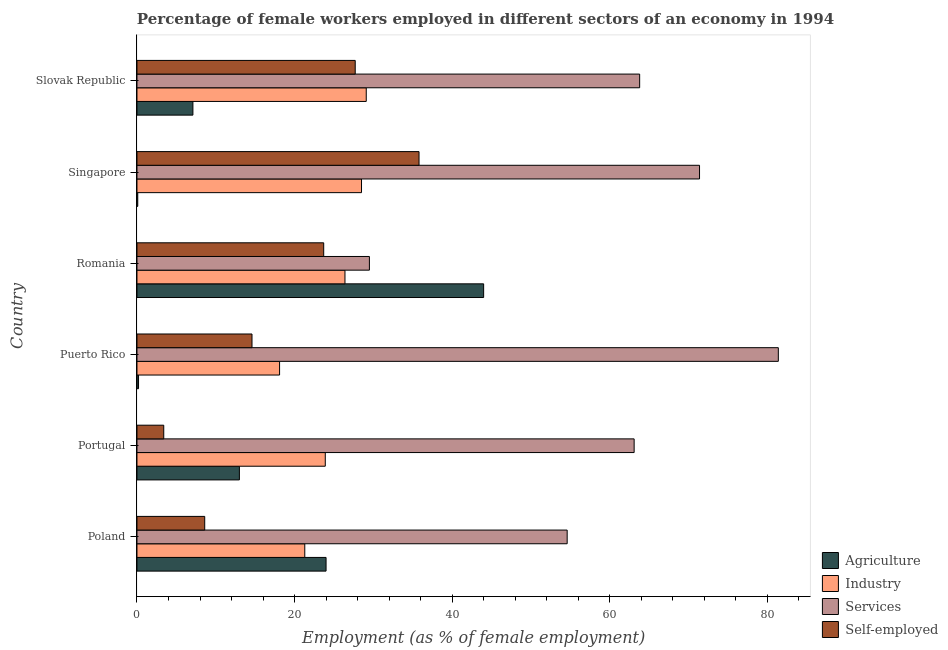How many groups of bars are there?
Offer a terse response. 6. Are the number of bars on each tick of the Y-axis equal?
Make the answer very short. Yes. What is the label of the 1st group of bars from the top?
Provide a succinct answer. Slovak Republic. In how many cases, is the number of bars for a given country not equal to the number of legend labels?
Make the answer very short. 0. What is the percentage of female workers in services in Romania?
Ensure brevity in your answer.  29.5. Across all countries, what is the minimum percentage of female workers in industry?
Keep it short and to the point. 18.1. In which country was the percentage of self employed female workers maximum?
Your answer should be very brief. Singapore. In which country was the percentage of female workers in agriculture minimum?
Your answer should be compact. Singapore. What is the total percentage of female workers in industry in the graph?
Offer a very short reply. 147.3. What is the difference between the percentage of female workers in services in Poland and the percentage of female workers in agriculture in Singapore?
Make the answer very short. 54.5. What is the average percentage of female workers in agriculture per country?
Give a very brief answer. 14.73. What is the difference between the percentage of self employed female workers and percentage of female workers in services in Slovak Republic?
Your answer should be compact. -36.1. What is the ratio of the percentage of female workers in industry in Puerto Rico to that in Slovak Republic?
Offer a terse response. 0.62. Is the percentage of female workers in services in Romania less than that in Slovak Republic?
Keep it short and to the point. Yes. What is the difference between the highest and the second highest percentage of female workers in agriculture?
Keep it short and to the point. 20. What is the difference between the highest and the lowest percentage of female workers in services?
Ensure brevity in your answer.  51.9. Is the sum of the percentage of self employed female workers in Puerto Rico and Romania greater than the maximum percentage of female workers in services across all countries?
Your answer should be very brief. No. What does the 4th bar from the top in Puerto Rico represents?
Make the answer very short. Agriculture. What does the 2nd bar from the bottom in Poland represents?
Give a very brief answer. Industry. Is it the case that in every country, the sum of the percentage of female workers in agriculture and percentage of female workers in industry is greater than the percentage of female workers in services?
Give a very brief answer. No. How many bars are there?
Provide a succinct answer. 24. How many countries are there in the graph?
Provide a succinct answer. 6. Are the values on the major ticks of X-axis written in scientific E-notation?
Keep it short and to the point. No. Does the graph contain grids?
Make the answer very short. No. Where does the legend appear in the graph?
Make the answer very short. Bottom right. What is the title of the graph?
Provide a short and direct response. Percentage of female workers employed in different sectors of an economy in 1994. Does "Agricultural land" appear as one of the legend labels in the graph?
Make the answer very short. No. What is the label or title of the X-axis?
Your answer should be compact. Employment (as % of female employment). What is the Employment (as % of female employment) of Agriculture in Poland?
Give a very brief answer. 24. What is the Employment (as % of female employment) of Industry in Poland?
Ensure brevity in your answer.  21.3. What is the Employment (as % of female employment) in Services in Poland?
Provide a succinct answer. 54.6. What is the Employment (as % of female employment) of Self-employed in Poland?
Provide a short and direct response. 8.6. What is the Employment (as % of female employment) of Industry in Portugal?
Give a very brief answer. 23.9. What is the Employment (as % of female employment) of Services in Portugal?
Offer a terse response. 63.1. What is the Employment (as % of female employment) of Self-employed in Portugal?
Offer a very short reply. 3.4. What is the Employment (as % of female employment) in Agriculture in Puerto Rico?
Your answer should be compact. 0.2. What is the Employment (as % of female employment) of Industry in Puerto Rico?
Keep it short and to the point. 18.1. What is the Employment (as % of female employment) of Services in Puerto Rico?
Ensure brevity in your answer.  81.4. What is the Employment (as % of female employment) of Self-employed in Puerto Rico?
Keep it short and to the point. 14.6. What is the Employment (as % of female employment) of Agriculture in Romania?
Keep it short and to the point. 44. What is the Employment (as % of female employment) in Industry in Romania?
Offer a very short reply. 26.4. What is the Employment (as % of female employment) in Services in Romania?
Keep it short and to the point. 29.5. What is the Employment (as % of female employment) in Self-employed in Romania?
Ensure brevity in your answer.  23.7. What is the Employment (as % of female employment) of Agriculture in Singapore?
Keep it short and to the point. 0.1. What is the Employment (as % of female employment) of Industry in Singapore?
Ensure brevity in your answer.  28.5. What is the Employment (as % of female employment) in Services in Singapore?
Give a very brief answer. 71.4. What is the Employment (as % of female employment) of Self-employed in Singapore?
Ensure brevity in your answer.  35.8. What is the Employment (as % of female employment) of Agriculture in Slovak Republic?
Your answer should be very brief. 7.1. What is the Employment (as % of female employment) of Industry in Slovak Republic?
Your response must be concise. 29.1. What is the Employment (as % of female employment) of Services in Slovak Republic?
Provide a succinct answer. 63.8. What is the Employment (as % of female employment) of Self-employed in Slovak Republic?
Your answer should be very brief. 27.7. Across all countries, what is the maximum Employment (as % of female employment) in Agriculture?
Provide a succinct answer. 44. Across all countries, what is the maximum Employment (as % of female employment) of Industry?
Offer a very short reply. 29.1. Across all countries, what is the maximum Employment (as % of female employment) of Services?
Your answer should be very brief. 81.4. Across all countries, what is the maximum Employment (as % of female employment) in Self-employed?
Your answer should be compact. 35.8. Across all countries, what is the minimum Employment (as % of female employment) in Agriculture?
Your answer should be very brief. 0.1. Across all countries, what is the minimum Employment (as % of female employment) in Industry?
Offer a terse response. 18.1. Across all countries, what is the minimum Employment (as % of female employment) of Services?
Offer a very short reply. 29.5. Across all countries, what is the minimum Employment (as % of female employment) of Self-employed?
Provide a succinct answer. 3.4. What is the total Employment (as % of female employment) of Agriculture in the graph?
Keep it short and to the point. 88.4. What is the total Employment (as % of female employment) in Industry in the graph?
Provide a succinct answer. 147.3. What is the total Employment (as % of female employment) in Services in the graph?
Ensure brevity in your answer.  363.8. What is the total Employment (as % of female employment) of Self-employed in the graph?
Ensure brevity in your answer.  113.8. What is the difference between the Employment (as % of female employment) of Agriculture in Poland and that in Portugal?
Your answer should be compact. 11. What is the difference between the Employment (as % of female employment) of Industry in Poland and that in Portugal?
Offer a terse response. -2.6. What is the difference between the Employment (as % of female employment) of Self-employed in Poland and that in Portugal?
Make the answer very short. 5.2. What is the difference between the Employment (as % of female employment) in Agriculture in Poland and that in Puerto Rico?
Make the answer very short. 23.8. What is the difference between the Employment (as % of female employment) in Services in Poland and that in Puerto Rico?
Give a very brief answer. -26.8. What is the difference between the Employment (as % of female employment) in Self-employed in Poland and that in Puerto Rico?
Your answer should be compact. -6. What is the difference between the Employment (as % of female employment) in Agriculture in Poland and that in Romania?
Your response must be concise. -20. What is the difference between the Employment (as % of female employment) of Services in Poland and that in Romania?
Give a very brief answer. 25.1. What is the difference between the Employment (as % of female employment) of Self-employed in Poland and that in Romania?
Your answer should be very brief. -15.1. What is the difference between the Employment (as % of female employment) of Agriculture in Poland and that in Singapore?
Keep it short and to the point. 23.9. What is the difference between the Employment (as % of female employment) of Services in Poland and that in Singapore?
Your answer should be very brief. -16.8. What is the difference between the Employment (as % of female employment) of Self-employed in Poland and that in Singapore?
Keep it short and to the point. -27.2. What is the difference between the Employment (as % of female employment) of Services in Poland and that in Slovak Republic?
Your answer should be compact. -9.2. What is the difference between the Employment (as % of female employment) in Self-employed in Poland and that in Slovak Republic?
Make the answer very short. -19.1. What is the difference between the Employment (as % of female employment) in Agriculture in Portugal and that in Puerto Rico?
Your answer should be very brief. 12.8. What is the difference between the Employment (as % of female employment) of Industry in Portugal and that in Puerto Rico?
Your answer should be compact. 5.8. What is the difference between the Employment (as % of female employment) of Services in Portugal and that in Puerto Rico?
Offer a terse response. -18.3. What is the difference between the Employment (as % of female employment) of Agriculture in Portugal and that in Romania?
Provide a succinct answer. -31. What is the difference between the Employment (as % of female employment) in Services in Portugal and that in Romania?
Provide a succinct answer. 33.6. What is the difference between the Employment (as % of female employment) of Self-employed in Portugal and that in Romania?
Ensure brevity in your answer.  -20.3. What is the difference between the Employment (as % of female employment) of Agriculture in Portugal and that in Singapore?
Provide a succinct answer. 12.9. What is the difference between the Employment (as % of female employment) of Industry in Portugal and that in Singapore?
Ensure brevity in your answer.  -4.6. What is the difference between the Employment (as % of female employment) of Self-employed in Portugal and that in Singapore?
Your answer should be very brief. -32.4. What is the difference between the Employment (as % of female employment) of Agriculture in Portugal and that in Slovak Republic?
Keep it short and to the point. 5.9. What is the difference between the Employment (as % of female employment) in Industry in Portugal and that in Slovak Republic?
Your response must be concise. -5.2. What is the difference between the Employment (as % of female employment) of Self-employed in Portugal and that in Slovak Republic?
Make the answer very short. -24.3. What is the difference between the Employment (as % of female employment) of Agriculture in Puerto Rico and that in Romania?
Ensure brevity in your answer.  -43.8. What is the difference between the Employment (as % of female employment) of Industry in Puerto Rico and that in Romania?
Give a very brief answer. -8.3. What is the difference between the Employment (as % of female employment) of Services in Puerto Rico and that in Romania?
Provide a short and direct response. 51.9. What is the difference between the Employment (as % of female employment) of Agriculture in Puerto Rico and that in Singapore?
Provide a succinct answer. 0.1. What is the difference between the Employment (as % of female employment) of Industry in Puerto Rico and that in Singapore?
Provide a succinct answer. -10.4. What is the difference between the Employment (as % of female employment) of Services in Puerto Rico and that in Singapore?
Your answer should be very brief. 10. What is the difference between the Employment (as % of female employment) in Self-employed in Puerto Rico and that in Singapore?
Keep it short and to the point. -21.2. What is the difference between the Employment (as % of female employment) of Agriculture in Puerto Rico and that in Slovak Republic?
Give a very brief answer. -6.9. What is the difference between the Employment (as % of female employment) in Industry in Puerto Rico and that in Slovak Republic?
Your response must be concise. -11. What is the difference between the Employment (as % of female employment) in Services in Puerto Rico and that in Slovak Republic?
Your answer should be very brief. 17.6. What is the difference between the Employment (as % of female employment) in Self-employed in Puerto Rico and that in Slovak Republic?
Give a very brief answer. -13.1. What is the difference between the Employment (as % of female employment) of Agriculture in Romania and that in Singapore?
Provide a short and direct response. 43.9. What is the difference between the Employment (as % of female employment) in Industry in Romania and that in Singapore?
Provide a succinct answer. -2.1. What is the difference between the Employment (as % of female employment) of Services in Romania and that in Singapore?
Provide a short and direct response. -41.9. What is the difference between the Employment (as % of female employment) of Self-employed in Romania and that in Singapore?
Offer a very short reply. -12.1. What is the difference between the Employment (as % of female employment) in Agriculture in Romania and that in Slovak Republic?
Provide a short and direct response. 36.9. What is the difference between the Employment (as % of female employment) of Services in Romania and that in Slovak Republic?
Offer a very short reply. -34.3. What is the difference between the Employment (as % of female employment) of Self-employed in Romania and that in Slovak Republic?
Ensure brevity in your answer.  -4. What is the difference between the Employment (as % of female employment) of Agriculture in Singapore and that in Slovak Republic?
Your answer should be compact. -7. What is the difference between the Employment (as % of female employment) in Industry in Singapore and that in Slovak Republic?
Make the answer very short. -0.6. What is the difference between the Employment (as % of female employment) of Services in Singapore and that in Slovak Republic?
Keep it short and to the point. 7.6. What is the difference between the Employment (as % of female employment) in Self-employed in Singapore and that in Slovak Republic?
Make the answer very short. 8.1. What is the difference between the Employment (as % of female employment) of Agriculture in Poland and the Employment (as % of female employment) of Industry in Portugal?
Provide a succinct answer. 0.1. What is the difference between the Employment (as % of female employment) of Agriculture in Poland and the Employment (as % of female employment) of Services in Portugal?
Your answer should be compact. -39.1. What is the difference between the Employment (as % of female employment) of Agriculture in Poland and the Employment (as % of female employment) of Self-employed in Portugal?
Keep it short and to the point. 20.6. What is the difference between the Employment (as % of female employment) of Industry in Poland and the Employment (as % of female employment) of Services in Portugal?
Keep it short and to the point. -41.8. What is the difference between the Employment (as % of female employment) of Industry in Poland and the Employment (as % of female employment) of Self-employed in Portugal?
Make the answer very short. 17.9. What is the difference between the Employment (as % of female employment) of Services in Poland and the Employment (as % of female employment) of Self-employed in Portugal?
Provide a succinct answer. 51.2. What is the difference between the Employment (as % of female employment) in Agriculture in Poland and the Employment (as % of female employment) in Services in Puerto Rico?
Give a very brief answer. -57.4. What is the difference between the Employment (as % of female employment) in Industry in Poland and the Employment (as % of female employment) in Services in Puerto Rico?
Offer a very short reply. -60.1. What is the difference between the Employment (as % of female employment) of Agriculture in Poland and the Employment (as % of female employment) of Industry in Romania?
Your answer should be very brief. -2.4. What is the difference between the Employment (as % of female employment) of Agriculture in Poland and the Employment (as % of female employment) of Services in Romania?
Ensure brevity in your answer.  -5.5. What is the difference between the Employment (as % of female employment) in Services in Poland and the Employment (as % of female employment) in Self-employed in Romania?
Ensure brevity in your answer.  30.9. What is the difference between the Employment (as % of female employment) in Agriculture in Poland and the Employment (as % of female employment) in Industry in Singapore?
Provide a succinct answer. -4.5. What is the difference between the Employment (as % of female employment) in Agriculture in Poland and the Employment (as % of female employment) in Services in Singapore?
Give a very brief answer. -47.4. What is the difference between the Employment (as % of female employment) of Industry in Poland and the Employment (as % of female employment) of Services in Singapore?
Offer a very short reply. -50.1. What is the difference between the Employment (as % of female employment) in Services in Poland and the Employment (as % of female employment) in Self-employed in Singapore?
Ensure brevity in your answer.  18.8. What is the difference between the Employment (as % of female employment) of Agriculture in Poland and the Employment (as % of female employment) of Industry in Slovak Republic?
Your answer should be very brief. -5.1. What is the difference between the Employment (as % of female employment) of Agriculture in Poland and the Employment (as % of female employment) of Services in Slovak Republic?
Your answer should be compact. -39.8. What is the difference between the Employment (as % of female employment) of Agriculture in Poland and the Employment (as % of female employment) of Self-employed in Slovak Republic?
Offer a very short reply. -3.7. What is the difference between the Employment (as % of female employment) of Industry in Poland and the Employment (as % of female employment) of Services in Slovak Republic?
Offer a terse response. -42.5. What is the difference between the Employment (as % of female employment) of Services in Poland and the Employment (as % of female employment) of Self-employed in Slovak Republic?
Offer a terse response. 26.9. What is the difference between the Employment (as % of female employment) in Agriculture in Portugal and the Employment (as % of female employment) in Industry in Puerto Rico?
Your answer should be very brief. -5.1. What is the difference between the Employment (as % of female employment) of Agriculture in Portugal and the Employment (as % of female employment) of Services in Puerto Rico?
Ensure brevity in your answer.  -68.4. What is the difference between the Employment (as % of female employment) in Agriculture in Portugal and the Employment (as % of female employment) in Self-employed in Puerto Rico?
Provide a short and direct response. -1.6. What is the difference between the Employment (as % of female employment) of Industry in Portugal and the Employment (as % of female employment) of Services in Puerto Rico?
Your answer should be very brief. -57.5. What is the difference between the Employment (as % of female employment) in Services in Portugal and the Employment (as % of female employment) in Self-employed in Puerto Rico?
Provide a succinct answer. 48.5. What is the difference between the Employment (as % of female employment) of Agriculture in Portugal and the Employment (as % of female employment) of Services in Romania?
Your response must be concise. -16.5. What is the difference between the Employment (as % of female employment) of Industry in Portugal and the Employment (as % of female employment) of Services in Romania?
Your response must be concise. -5.6. What is the difference between the Employment (as % of female employment) of Services in Portugal and the Employment (as % of female employment) of Self-employed in Romania?
Provide a succinct answer. 39.4. What is the difference between the Employment (as % of female employment) of Agriculture in Portugal and the Employment (as % of female employment) of Industry in Singapore?
Make the answer very short. -15.5. What is the difference between the Employment (as % of female employment) in Agriculture in Portugal and the Employment (as % of female employment) in Services in Singapore?
Provide a short and direct response. -58.4. What is the difference between the Employment (as % of female employment) in Agriculture in Portugal and the Employment (as % of female employment) in Self-employed in Singapore?
Make the answer very short. -22.8. What is the difference between the Employment (as % of female employment) in Industry in Portugal and the Employment (as % of female employment) in Services in Singapore?
Your answer should be compact. -47.5. What is the difference between the Employment (as % of female employment) of Services in Portugal and the Employment (as % of female employment) of Self-employed in Singapore?
Make the answer very short. 27.3. What is the difference between the Employment (as % of female employment) in Agriculture in Portugal and the Employment (as % of female employment) in Industry in Slovak Republic?
Give a very brief answer. -16.1. What is the difference between the Employment (as % of female employment) in Agriculture in Portugal and the Employment (as % of female employment) in Services in Slovak Republic?
Keep it short and to the point. -50.8. What is the difference between the Employment (as % of female employment) in Agriculture in Portugal and the Employment (as % of female employment) in Self-employed in Slovak Republic?
Give a very brief answer. -14.7. What is the difference between the Employment (as % of female employment) of Industry in Portugal and the Employment (as % of female employment) of Services in Slovak Republic?
Ensure brevity in your answer.  -39.9. What is the difference between the Employment (as % of female employment) of Industry in Portugal and the Employment (as % of female employment) of Self-employed in Slovak Republic?
Ensure brevity in your answer.  -3.8. What is the difference between the Employment (as % of female employment) of Services in Portugal and the Employment (as % of female employment) of Self-employed in Slovak Republic?
Your answer should be compact. 35.4. What is the difference between the Employment (as % of female employment) in Agriculture in Puerto Rico and the Employment (as % of female employment) in Industry in Romania?
Give a very brief answer. -26.2. What is the difference between the Employment (as % of female employment) in Agriculture in Puerto Rico and the Employment (as % of female employment) in Services in Romania?
Your answer should be very brief. -29.3. What is the difference between the Employment (as % of female employment) in Agriculture in Puerto Rico and the Employment (as % of female employment) in Self-employed in Romania?
Your answer should be very brief. -23.5. What is the difference between the Employment (as % of female employment) of Industry in Puerto Rico and the Employment (as % of female employment) of Services in Romania?
Your answer should be compact. -11.4. What is the difference between the Employment (as % of female employment) of Industry in Puerto Rico and the Employment (as % of female employment) of Self-employed in Romania?
Make the answer very short. -5.6. What is the difference between the Employment (as % of female employment) of Services in Puerto Rico and the Employment (as % of female employment) of Self-employed in Romania?
Provide a short and direct response. 57.7. What is the difference between the Employment (as % of female employment) in Agriculture in Puerto Rico and the Employment (as % of female employment) in Industry in Singapore?
Provide a succinct answer. -28.3. What is the difference between the Employment (as % of female employment) in Agriculture in Puerto Rico and the Employment (as % of female employment) in Services in Singapore?
Your answer should be compact. -71.2. What is the difference between the Employment (as % of female employment) of Agriculture in Puerto Rico and the Employment (as % of female employment) of Self-employed in Singapore?
Your answer should be very brief. -35.6. What is the difference between the Employment (as % of female employment) in Industry in Puerto Rico and the Employment (as % of female employment) in Services in Singapore?
Offer a very short reply. -53.3. What is the difference between the Employment (as % of female employment) in Industry in Puerto Rico and the Employment (as % of female employment) in Self-employed in Singapore?
Offer a very short reply. -17.7. What is the difference between the Employment (as % of female employment) of Services in Puerto Rico and the Employment (as % of female employment) of Self-employed in Singapore?
Your response must be concise. 45.6. What is the difference between the Employment (as % of female employment) in Agriculture in Puerto Rico and the Employment (as % of female employment) in Industry in Slovak Republic?
Offer a very short reply. -28.9. What is the difference between the Employment (as % of female employment) in Agriculture in Puerto Rico and the Employment (as % of female employment) in Services in Slovak Republic?
Ensure brevity in your answer.  -63.6. What is the difference between the Employment (as % of female employment) of Agriculture in Puerto Rico and the Employment (as % of female employment) of Self-employed in Slovak Republic?
Your response must be concise. -27.5. What is the difference between the Employment (as % of female employment) of Industry in Puerto Rico and the Employment (as % of female employment) of Services in Slovak Republic?
Your response must be concise. -45.7. What is the difference between the Employment (as % of female employment) in Services in Puerto Rico and the Employment (as % of female employment) in Self-employed in Slovak Republic?
Your answer should be very brief. 53.7. What is the difference between the Employment (as % of female employment) of Agriculture in Romania and the Employment (as % of female employment) of Industry in Singapore?
Your response must be concise. 15.5. What is the difference between the Employment (as % of female employment) in Agriculture in Romania and the Employment (as % of female employment) in Services in Singapore?
Ensure brevity in your answer.  -27.4. What is the difference between the Employment (as % of female employment) in Industry in Romania and the Employment (as % of female employment) in Services in Singapore?
Keep it short and to the point. -45. What is the difference between the Employment (as % of female employment) of Agriculture in Romania and the Employment (as % of female employment) of Services in Slovak Republic?
Provide a short and direct response. -19.8. What is the difference between the Employment (as % of female employment) in Industry in Romania and the Employment (as % of female employment) in Services in Slovak Republic?
Your answer should be very brief. -37.4. What is the difference between the Employment (as % of female employment) of Services in Romania and the Employment (as % of female employment) of Self-employed in Slovak Republic?
Offer a terse response. 1.8. What is the difference between the Employment (as % of female employment) in Agriculture in Singapore and the Employment (as % of female employment) in Services in Slovak Republic?
Make the answer very short. -63.7. What is the difference between the Employment (as % of female employment) in Agriculture in Singapore and the Employment (as % of female employment) in Self-employed in Slovak Republic?
Ensure brevity in your answer.  -27.6. What is the difference between the Employment (as % of female employment) of Industry in Singapore and the Employment (as % of female employment) of Services in Slovak Republic?
Your answer should be very brief. -35.3. What is the difference between the Employment (as % of female employment) in Services in Singapore and the Employment (as % of female employment) in Self-employed in Slovak Republic?
Your response must be concise. 43.7. What is the average Employment (as % of female employment) in Agriculture per country?
Offer a terse response. 14.73. What is the average Employment (as % of female employment) of Industry per country?
Provide a short and direct response. 24.55. What is the average Employment (as % of female employment) of Services per country?
Ensure brevity in your answer.  60.63. What is the average Employment (as % of female employment) of Self-employed per country?
Offer a terse response. 18.97. What is the difference between the Employment (as % of female employment) of Agriculture and Employment (as % of female employment) of Industry in Poland?
Offer a terse response. 2.7. What is the difference between the Employment (as % of female employment) of Agriculture and Employment (as % of female employment) of Services in Poland?
Keep it short and to the point. -30.6. What is the difference between the Employment (as % of female employment) of Agriculture and Employment (as % of female employment) of Self-employed in Poland?
Your answer should be compact. 15.4. What is the difference between the Employment (as % of female employment) in Industry and Employment (as % of female employment) in Services in Poland?
Offer a terse response. -33.3. What is the difference between the Employment (as % of female employment) in Industry and Employment (as % of female employment) in Self-employed in Poland?
Provide a short and direct response. 12.7. What is the difference between the Employment (as % of female employment) in Agriculture and Employment (as % of female employment) in Services in Portugal?
Ensure brevity in your answer.  -50.1. What is the difference between the Employment (as % of female employment) in Industry and Employment (as % of female employment) in Services in Portugal?
Provide a succinct answer. -39.2. What is the difference between the Employment (as % of female employment) of Services and Employment (as % of female employment) of Self-employed in Portugal?
Offer a very short reply. 59.7. What is the difference between the Employment (as % of female employment) in Agriculture and Employment (as % of female employment) in Industry in Puerto Rico?
Ensure brevity in your answer.  -17.9. What is the difference between the Employment (as % of female employment) of Agriculture and Employment (as % of female employment) of Services in Puerto Rico?
Offer a very short reply. -81.2. What is the difference between the Employment (as % of female employment) of Agriculture and Employment (as % of female employment) of Self-employed in Puerto Rico?
Make the answer very short. -14.4. What is the difference between the Employment (as % of female employment) of Industry and Employment (as % of female employment) of Services in Puerto Rico?
Make the answer very short. -63.3. What is the difference between the Employment (as % of female employment) in Services and Employment (as % of female employment) in Self-employed in Puerto Rico?
Make the answer very short. 66.8. What is the difference between the Employment (as % of female employment) of Agriculture and Employment (as % of female employment) of Industry in Romania?
Make the answer very short. 17.6. What is the difference between the Employment (as % of female employment) in Agriculture and Employment (as % of female employment) in Services in Romania?
Ensure brevity in your answer.  14.5. What is the difference between the Employment (as % of female employment) in Agriculture and Employment (as % of female employment) in Self-employed in Romania?
Your answer should be compact. 20.3. What is the difference between the Employment (as % of female employment) in Industry and Employment (as % of female employment) in Services in Romania?
Your answer should be very brief. -3.1. What is the difference between the Employment (as % of female employment) of Services and Employment (as % of female employment) of Self-employed in Romania?
Keep it short and to the point. 5.8. What is the difference between the Employment (as % of female employment) of Agriculture and Employment (as % of female employment) of Industry in Singapore?
Your response must be concise. -28.4. What is the difference between the Employment (as % of female employment) of Agriculture and Employment (as % of female employment) of Services in Singapore?
Ensure brevity in your answer.  -71.3. What is the difference between the Employment (as % of female employment) in Agriculture and Employment (as % of female employment) in Self-employed in Singapore?
Your answer should be compact. -35.7. What is the difference between the Employment (as % of female employment) of Industry and Employment (as % of female employment) of Services in Singapore?
Ensure brevity in your answer.  -42.9. What is the difference between the Employment (as % of female employment) in Services and Employment (as % of female employment) in Self-employed in Singapore?
Your answer should be very brief. 35.6. What is the difference between the Employment (as % of female employment) in Agriculture and Employment (as % of female employment) in Services in Slovak Republic?
Provide a short and direct response. -56.7. What is the difference between the Employment (as % of female employment) in Agriculture and Employment (as % of female employment) in Self-employed in Slovak Republic?
Provide a succinct answer. -20.6. What is the difference between the Employment (as % of female employment) of Industry and Employment (as % of female employment) of Services in Slovak Republic?
Offer a very short reply. -34.7. What is the difference between the Employment (as % of female employment) of Services and Employment (as % of female employment) of Self-employed in Slovak Republic?
Make the answer very short. 36.1. What is the ratio of the Employment (as % of female employment) of Agriculture in Poland to that in Portugal?
Your answer should be compact. 1.85. What is the ratio of the Employment (as % of female employment) in Industry in Poland to that in Portugal?
Offer a very short reply. 0.89. What is the ratio of the Employment (as % of female employment) in Services in Poland to that in Portugal?
Provide a succinct answer. 0.87. What is the ratio of the Employment (as % of female employment) in Self-employed in Poland to that in Portugal?
Ensure brevity in your answer.  2.53. What is the ratio of the Employment (as % of female employment) of Agriculture in Poland to that in Puerto Rico?
Your answer should be compact. 120. What is the ratio of the Employment (as % of female employment) in Industry in Poland to that in Puerto Rico?
Keep it short and to the point. 1.18. What is the ratio of the Employment (as % of female employment) of Services in Poland to that in Puerto Rico?
Offer a terse response. 0.67. What is the ratio of the Employment (as % of female employment) of Self-employed in Poland to that in Puerto Rico?
Make the answer very short. 0.59. What is the ratio of the Employment (as % of female employment) in Agriculture in Poland to that in Romania?
Offer a very short reply. 0.55. What is the ratio of the Employment (as % of female employment) in Industry in Poland to that in Romania?
Your response must be concise. 0.81. What is the ratio of the Employment (as % of female employment) of Services in Poland to that in Romania?
Your answer should be very brief. 1.85. What is the ratio of the Employment (as % of female employment) in Self-employed in Poland to that in Romania?
Make the answer very short. 0.36. What is the ratio of the Employment (as % of female employment) of Agriculture in Poland to that in Singapore?
Keep it short and to the point. 240. What is the ratio of the Employment (as % of female employment) in Industry in Poland to that in Singapore?
Provide a succinct answer. 0.75. What is the ratio of the Employment (as % of female employment) in Services in Poland to that in Singapore?
Make the answer very short. 0.76. What is the ratio of the Employment (as % of female employment) of Self-employed in Poland to that in Singapore?
Your answer should be very brief. 0.24. What is the ratio of the Employment (as % of female employment) in Agriculture in Poland to that in Slovak Republic?
Keep it short and to the point. 3.38. What is the ratio of the Employment (as % of female employment) in Industry in Poland to that in Slovak Republic?
Provide a succinct answer. 0.73. What is the ratio of the Employment (as % of female employment) of Services in Poland to that in Slovak Republic?
Your response must be concise. 0.86. What is the ratio of the Employment (as % of female employment) of Self-employed in Poland to that in Slovak Republic?
Offer a terse response. 0.31. What is the ratio of the Employment (as % of female employment) in Industry in Portugal to that in Puerto Rico?
Offer a terse response. 1.32. What is the ratio of the Employment (as % of female employment) of Services in Portugal to that in Puerto Rico?
Your answer should be very brief. 0.78. What is the ratio of the Employment (as % of female employment) in Self-employed in Portugal to that in Puerto Rico?
Keep it short and to the point. 0.23. What is the ratio of the Employment (as % of female employment) of Agriculture in Portugal to that in Romania?
Keep it short and to the point. 0.3. What is the ratio of the Employment (as % of female employment) of Industry in Portugal to that in Romania?
Keep it short and to the point. 0.91. What is the ratio of the Employment (as % of female employment) in Services in Portugal to that in Romania?
Offer a very short reply. 2.14. What is the ratio of the Employment (as % of female employment) in Self-employed in Portugal to that in Romania?
Ensure brevity in your answer.  0.14. What is the ratio of the Employment (as % of female employment) in Agriculture in Portugal to that in Singapore?
Provide a succinct answer. 130. What is the ratio of the Employment (as % of female employment) of Industry in Portugal to that in Singapore?
Your response must be concise. 0.84. What is the ratio of the Employment (as % of female employment) of Services in Portugal to that in Singapore?
Make the answer very short. 0.88. What is the ratio of the Employment (as % of female employment) in Self-employed in Portugal to that in Singapore?
Make the answer very short. 0.1. What is the ratio of the Employment (as % of female employment) in Agriculture in Portugal to that in Slovak Republic?
Provide a succinct answer. 1.83. What is the ratio of the Employment (as % of female employment) of Industry in Portugal to that in Slovak Republic?
Offer a very short reply. 0.82. What is the ratio of the Employment (as % of female employment) of Services in Portugal to that in Slovak Republic?
Provide a succinct answer. 0.99. What is the ratio of the Employment (as % of female employment) in Self-employed in Portugal to that in Slovak Republic?
Keep it short and to the point. 0.12. What is the ratio of the Employment (as % of female employment) of Agriculture in Puerto Rico to that in Romania?
Provide a short and direct response. 0. What is the ratio of the Employment (as % of female employment) of Industry in Puerto Rico to that in Romania?
Offer a terse response. 0.69. What is the ratio of the Employment (as % of female employment) of Services in Puerto Rico to that in Romania?
Ensure brevity in your answer.  2.76. What is the ratio of the Employment (as % of female employment) of Self-employed in Puerto Rico to that in Romania?
Make the answer very short. 0.62. What is the ratio of the Employment (as % of female employment) of Agriculture in Puerto Rico to that in Singapore?
Make the answer very short. 2. What is the ratio of the Employment (as % of female employment) of Industry in Puerto Rico to that in Singapore?
Provide a succinct answer. 0.64. What is the ratio of the Employment (as % of female employment) of Services in Puerto Rico to that in Singapore?
Make the answer very short. 1.14. What is the ratio of the Employment (as % of female employment) of Self-employed in Puerto Rico to that in Singapore?
Your response must be concise. 0.41. What is the ratio of the Employment (as % of female employment) in Agriculture in Puerto Rico to that in Slovak Republic?
Provide a succinct answer. 0.03. What is the ratio of the Employment (as % of female employment) of Industry in Puerto Rico to that in Slovak Republic?
Keep it short and to the point. 0.62. What is the ratio of the Employment (as % of female employment) of Services in Puerto Rico to that in Slovak Republic?
Your answer should be very brief. 1.28. What is the ratio of the Employment (as % of female employment) of Self-employed in Puerto Rico to that in Slovak Republic?
Keep it short and to the point. 0.53. What is the ratio of the Employment (as % of female employment) of Agriculture in Romania to that in Singapore?
Your answer should be very brief. 440. What is the ratio of the Employment (as % of female employment) in Industry in Romania to that in Singapore?
Make the answer very short. 0.93. What is the ratio of the Employment (as % of female employment) of Services in Romania to that in Singapore?
Offer a terse response. 0.41. What is the ratio of the Employment (as % of female employment) in Self-employed in Romania to that in Singapore?
Offer a very short reply. 0.66. What is the ratio of the Employment (as % of female employment) of Agriculture in Romania to that in Slovak Republic?
Make the answer very short. 6.2. What is the ratio of the Employment (as % of female employment) of Industry in Romania to that in Slovak Republic?
Ensure brevity in your answer.  0.91. What is the ratio of the Employment (as % of female employment) in Services in Romania to that in Slovak Republic?
Provide a short and direct response. 0.46. What is the ratio of the Employment (as % of female employment) of Self-employed in Romania to that in Slovak Republic?
Keep it short and to the point. 0.86. What is the ratio of the Employment (as % of female employment) in Agriculture in Singapore to that in Slovak Republic?
Keep it short and to the point. 0.01. What is the ratio of the Employment (as % of female employment) of Industry in Singapore to that in Slovak Republic?
Offer a terse response. 0.98. What is the ratio of the Employment (as % of female employment) in Services in Singapore to that in Slovak Republic?
Make the answer very short. 1.12. What is the ratio of the Employment (as % of female employment) in Self-employed in Singapore to that in Slovak Republic?
Offer a very short reply. 1.29. What is the difference between the highest and the second highest Employment (as % of female employment) of Agriculture?
Offer a terse response. 20. What is the difference between the highest and the lowest Employment (as % of female employment) in Agriculture?
Make the answer very short. 43.9. What is the difference between the highest and the lowest Employment (as % of female employment) in Industry?
Your answer should be very brief. 11. What is the difference between the highest and the lowest Employment (as % of female employment) in Services?
Make the answer very short. 51.9. What is the difference between the highest and the lowest Employment (as % of female employment) in Self-employed?
Your response must be concise. 32.4. 